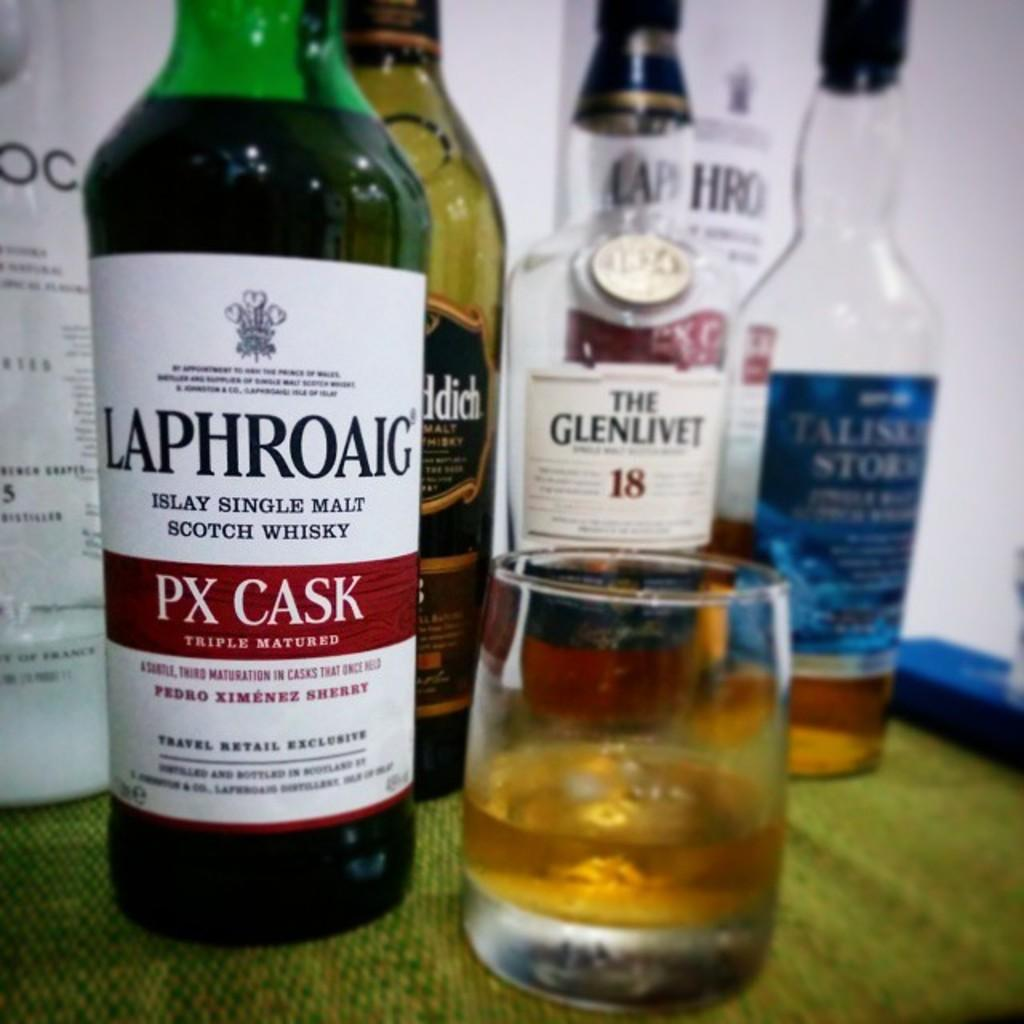<image>
Provide a brief description of the given image. A glass of whiskey sits next to a bottle of Laphroaig. 